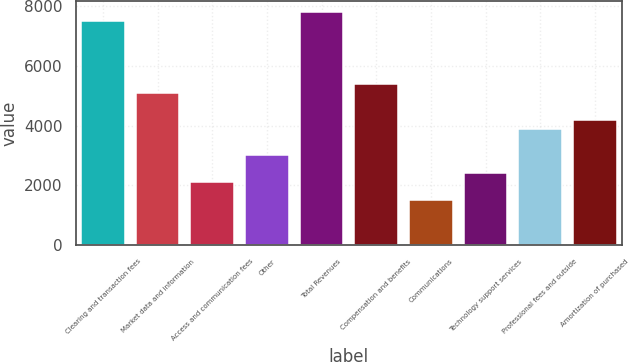<chart> <loc_0><loc_0><loc_500><loc_500><bar_chart><fcel>Clearing and transaction fees<fcel>Market data and information<fcel>Access and communication fees<fcel>Other<fcel>Total Revenues<fcel>Compensation and benefits<fcel>Communications<fcel>Technology support services<fcel>Professional fees and outside<fcel>Amortization of purchased<nl><fcel>7508.2<fcel>5105.8<fcel>2102.8<fcel>3003.7<fcel>7808.5<fcel>5406.1<fcel>1502.2<fcel>2403.1<fcel>3904.6<fcel>4204.9<nl></chart> 